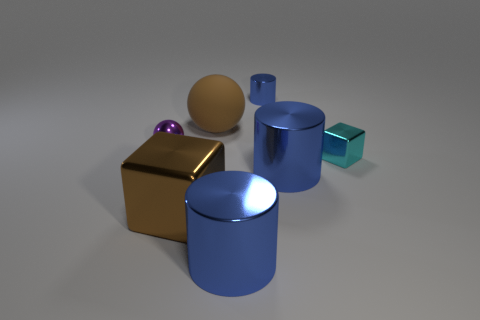Subtract 2 balls. How many balls are left? 0 Subtract all red cylinders. Subtract all green spheres. How many cylinders are left? 3 Add 1 blocks. How many objects exist? 8 Subtract all spheres. How many objects are left? 5 Add 3 brown balls. How many brown balls exist? 4 Subtract 0 yellow cylinders. How many objects are left? 7 Subtract all cylinders. Subtract all tiny blue metal cylinders. How many objects are left? 3 Add 1 tiny purple things. How many tiny purple things are left? 2 